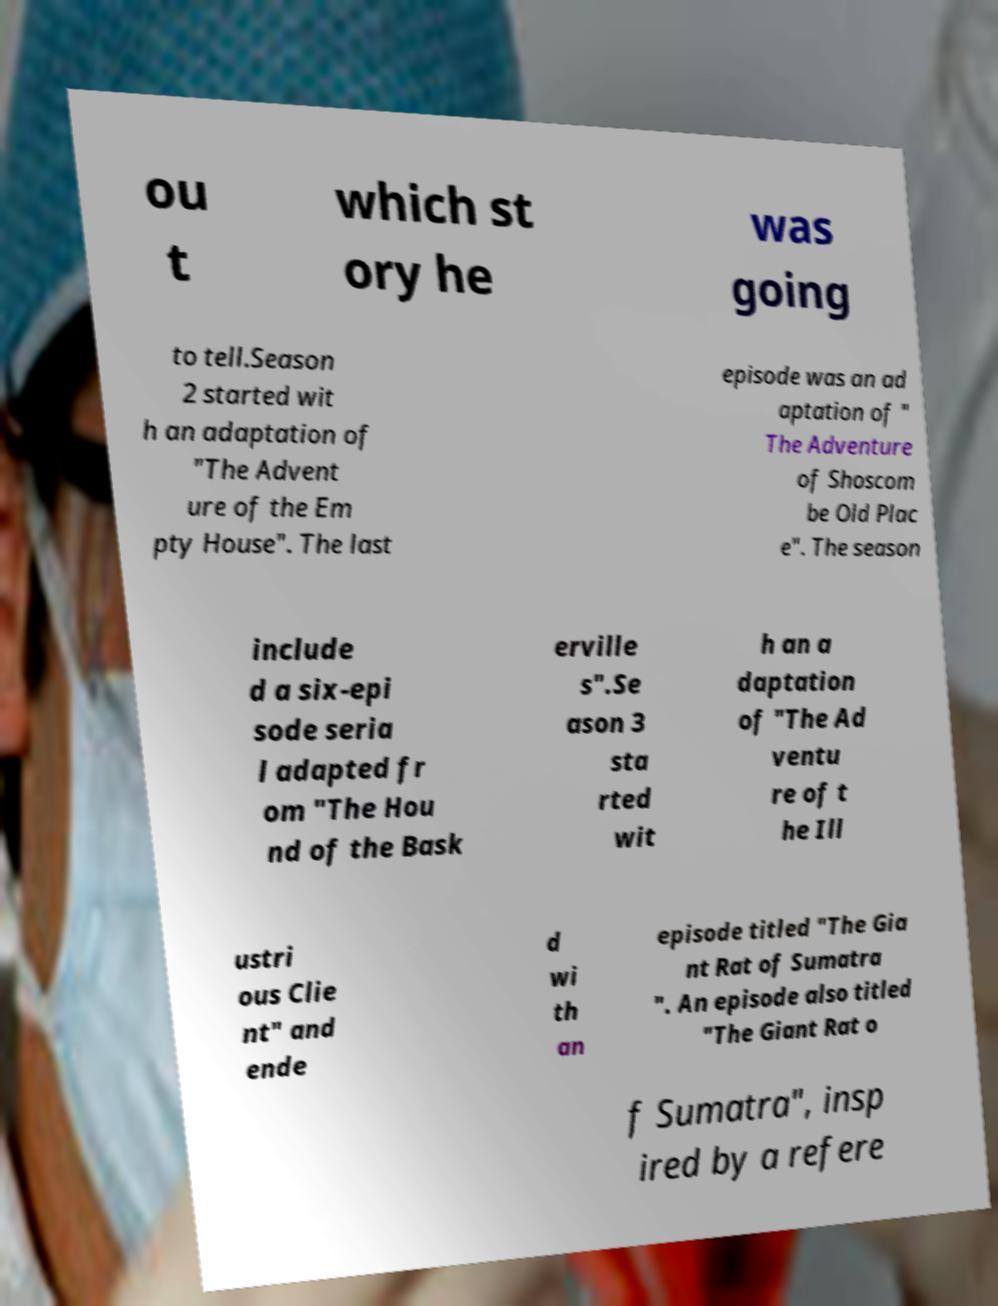Can you accurately transcribe the text from the provided image for me? ou t which st ory he was going to tell.Season 2 started wit h an adaptation of "The Advent ure of the Em pty House". The last episode was an ad aptation of " The Adventure of Shoscom be Old Plac e". The season include d a six-epi sode seria l adapted fr om "The Hou nd of the Bask erville s".Se ason 3 sta rted wit h an a daptation of "The Ad ventu re of t he Ill ustri ous Clie nt" and ende d wi th an episode titled "The Gia nt Rat of Sumatra ". An episode also titled "The Giant Rat o f Sumatra", insp ired by a refere 